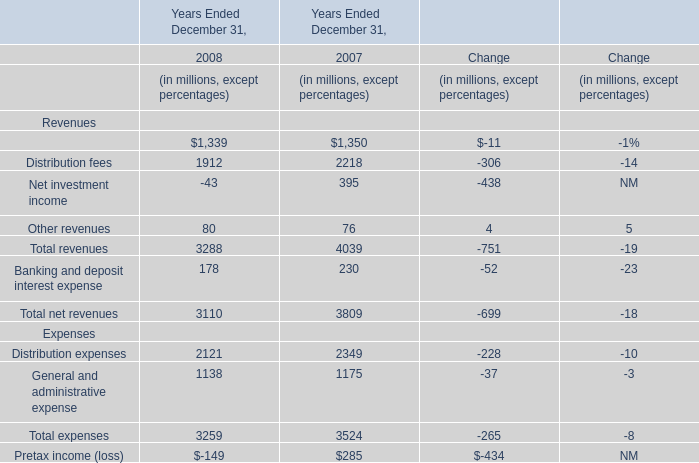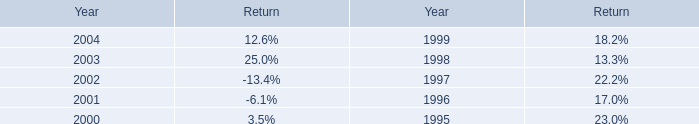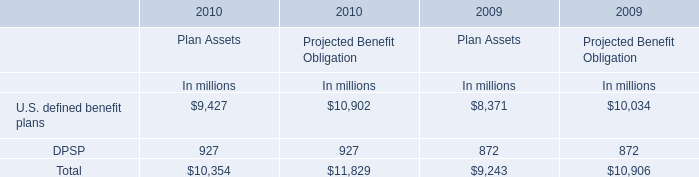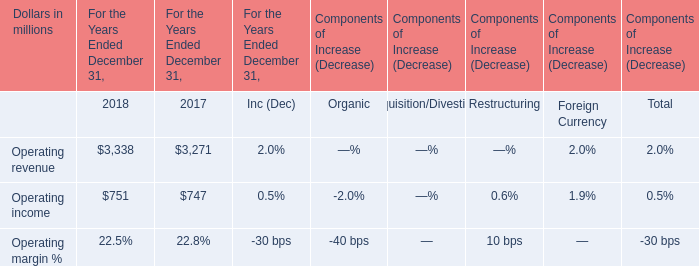What was the sum of Revenues without those Net investment income smaller than 0 in 2008? (in million) 
Computations: ((1339 + 1912) + 80)
Answer: 3331.0. 